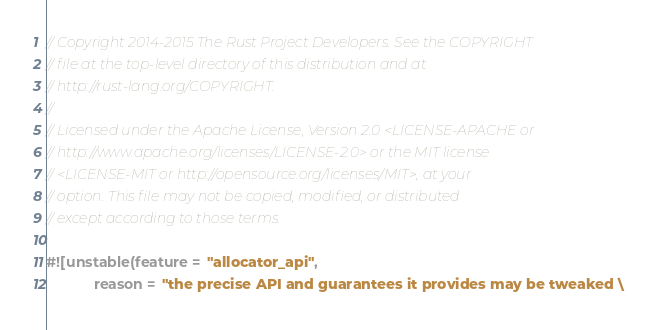Convert code to text. <code><loc_0><loc_0><loc_500><loc_500><_Rust_>// Copyright 2014-2015 The Rust Project Developers. See the COPYRIGHT
// file at the top-level directory of this distribution and at
// http://rust-lang.org/COPYRIGHT.
//
// Licensed under the Apache License, Version 2.0 <LICENSE-APACHE or
// http://www.apache.org/licenses/LICENSE-2.0> or the MIT license
// <LICENSE-MIT or http://opensource.org/licenses/MIT>, at your
// option. This file may not be copied, modified, or distributed
// except according to those terms.

#![unstable(feature = "allocator_api",
            reason = "the precise API and guarantees it provides may be tweaked \</code> 